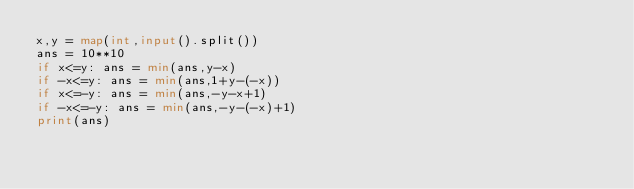Convert code to text. <code><loc_0><loc_0><loc_500><loc_500><_Python_>x,y = map(int,input().split())
ans = 10**10
if x<=y: ans = min(ans,y-x)
if -x<=y: ans = min(ans,1+y-(-x))
if x<=-y: ans = min(ans,-y-x+1)
if -x<=-y: ans = min(ans,-y-(-x)+1)
print(ans)
</code> 